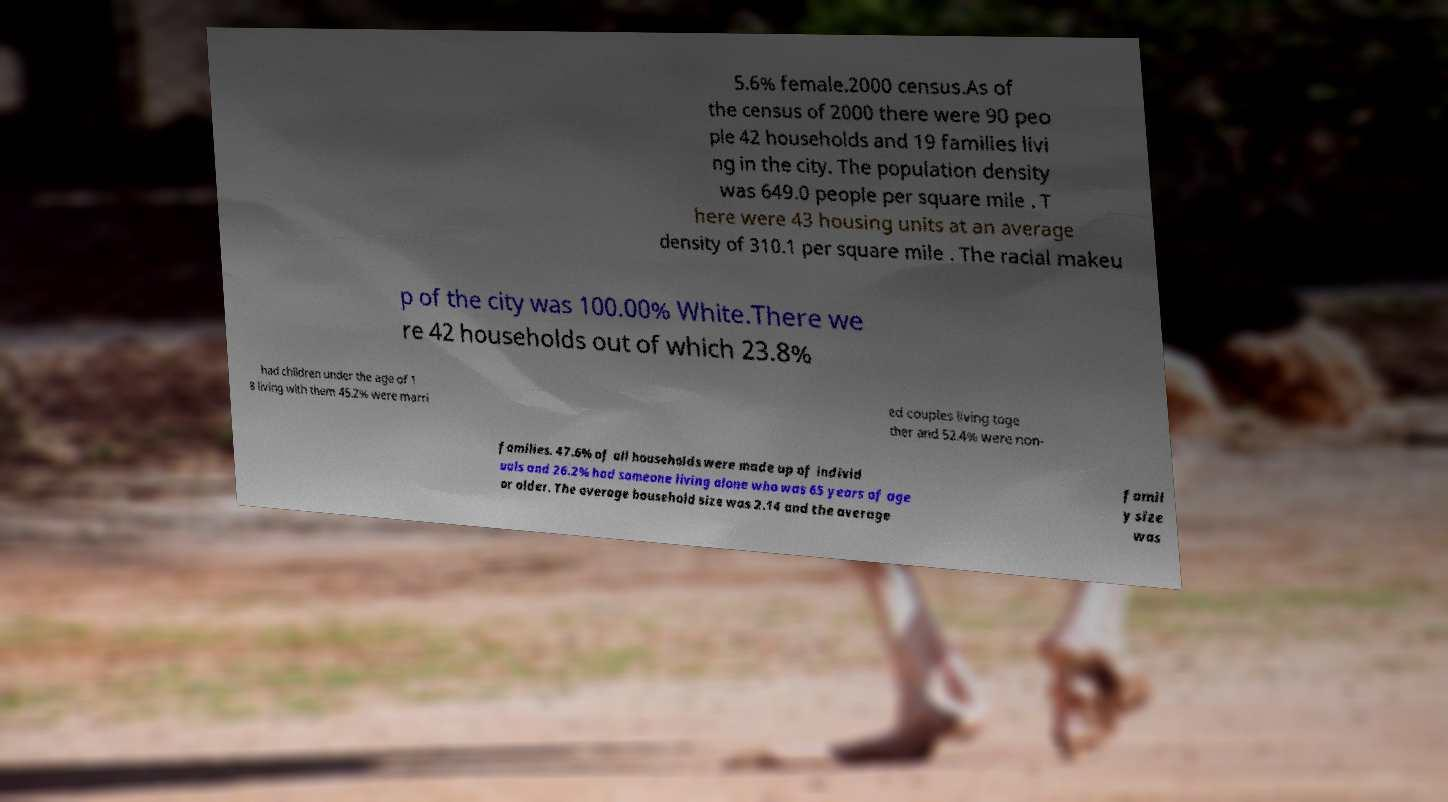Could you extract and type out the text from this image? 5.6% female.2000 census.As of the census of 2000 there were 90 peo ple 42 households and 19 families livi ng in the city. The population density was 649.0 people per square mile . T here were 43 housing units at an average density of 310.1 per square mile . The racial makeu p of the city was 100.00% White.There we re 42 households out of which 23.8% had children under the age of 1 8 living with them 45.2% were marri ed couples living toge ther and 52.4% were non- families. 47.6% of all households were made up of individ uals and 26.2% had someone living alone who was 65 years of age or older. The average household size was 2.14 and the average famil y size was 